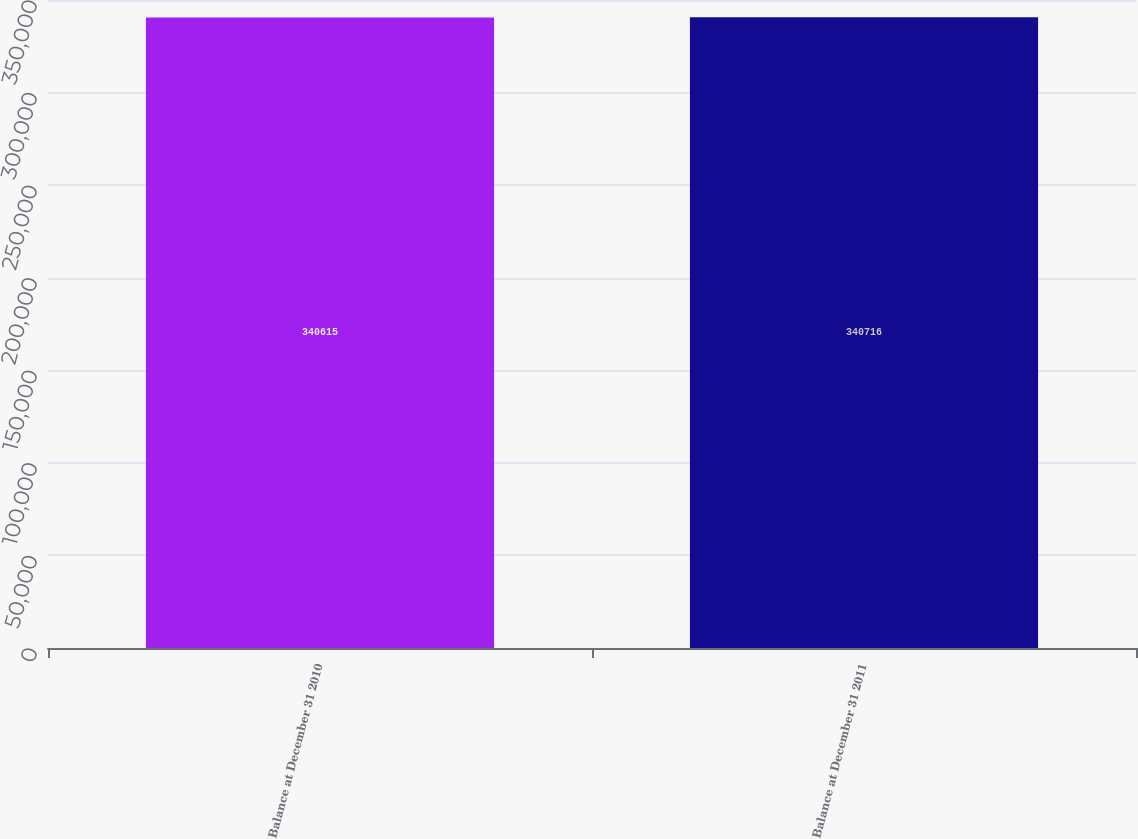<chart> <loc_0><loc_0><loc_500><loc_500><bar_chart><fcel>Balance at December 31 2010<fcel>Balance at December 31 2011<nl><fcel>340615<fcel>340716<nl></chart> 